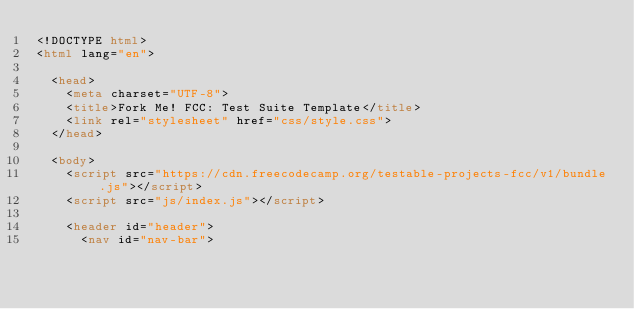Convert code to text. <code><loc_0><loc_0><loc_500><loc_500><_HTML_><!DOCTYPE html>
<html lang="en">

  <head>
    <meta charset="UTF-8">
    <title>Fork Me! FCC: Test Suite Template</title>
    <link rel="stylesheet" href="css/style.css">
  </head>
  
  <body>
    <script src="https://cdn.freecodecamp.org/testable-projects-fcc/v1/bundle.js"></script>
    <script src="js/index.js"></script>
  
    <header id="header">
      <nav id="nav-bar"></code> 